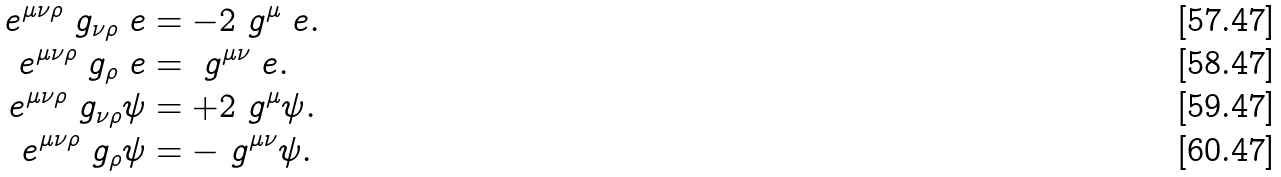Convert formula to latex. <formula><loc_0><loc_0><loc_500><loc_500>\ e ^ { \mu \nu \rho } \ g _ { \nu \rho } \ e & = - 2 \ g ^ { \mu } \ e . \\ \ e ^ { \mu \nu \rho } \ g _ { \rho } \ e & = \ g ^ { \mu \nu } \ e . \\ \ e ^ { \mu \nu \rho } \ g _ { \nu \rho } \psi & = + 2 \ g ^ { \mu } \psi . \\ \ e ^ { \mu \nu \rho } \ g _ { \rho } \psi & = - \ g ^ { \mu \nu } \psi .</formula> 